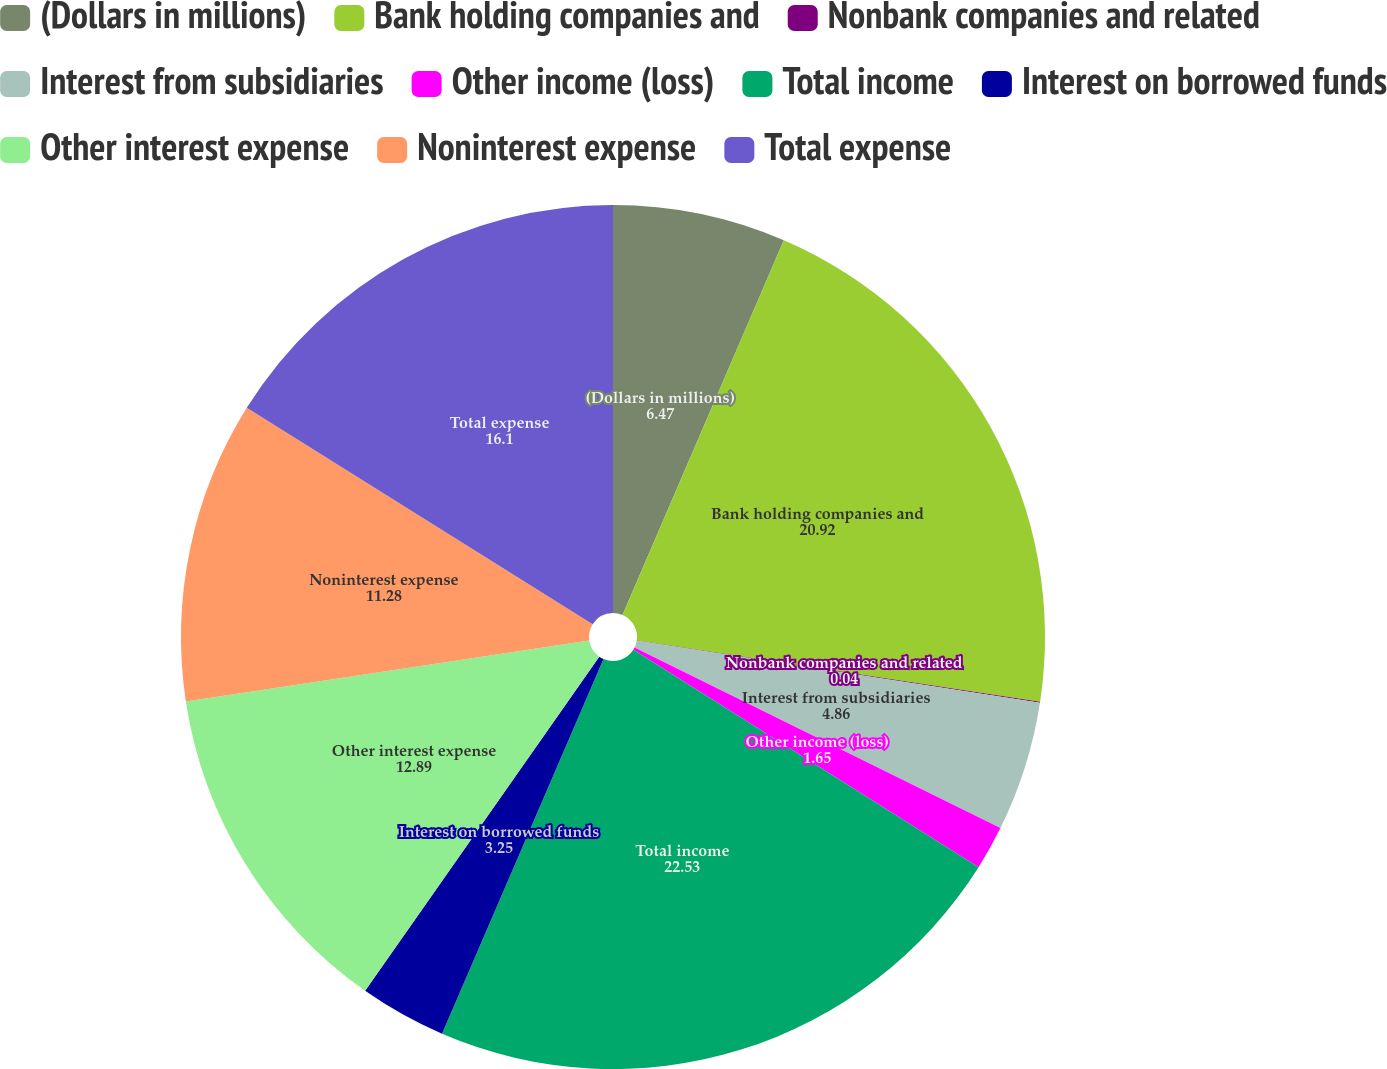<chart> <loc_0><loc_0><loc_500><loc_500><pie_chart><fcel>(Dollars in millions)<fcel>Bank holding companies and<fcel>Nonbank companies and related<fcel>Interest from subsidiaries<fcel>Other income (loss)<fcel>Total income<fcel>Interest on borrowed funds<fcel>Other interest expense<fcel>Noninterest expense<fcel>Total expense<nl><fcel>6.47%<fcel>20.92%<fcel>0.04%<fcel>4.86%<fcel>1.65%<fcel>22.53%<fcel>3.25%<fcel>12.89%<fcel>11.28%<fcel>16.1%<nl></chart> 